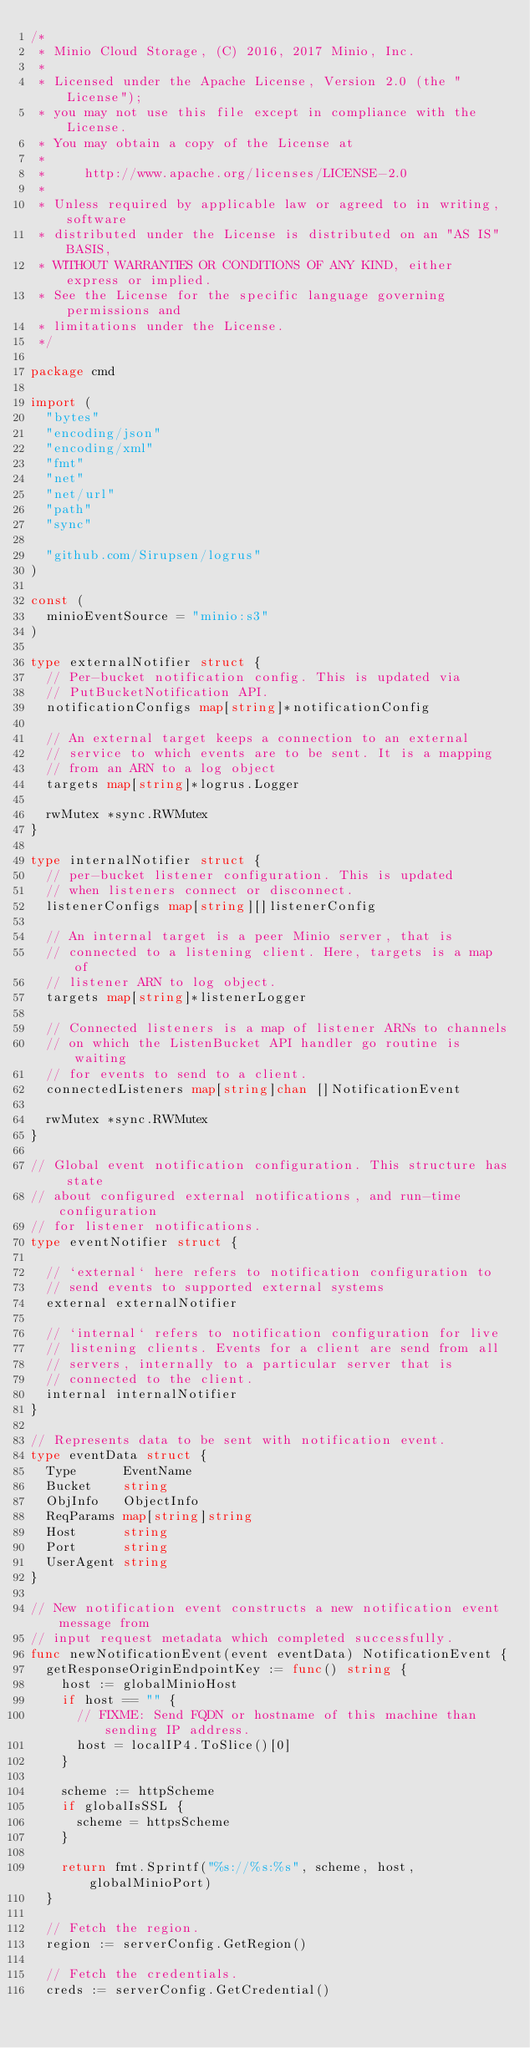<code> <loc_0><loc_0><loc_500><loc_500><_Go_>/*
 * Minio Cloud Storage, (C) 2016, 2017 Minio, Inc.
 *
 * Licensed under the Apache License, Version 2.0 (the "License");
 * you may not use this file except in compliance with the License.
 * You may obtain a copy of the License at
 *
 *     http://www.apache.org/licenses/LICENSE-2.0
 *
 * Unless required by applicable law or agreed to in writing, software
 * distributed under the License is distributed on an "AS IS" BASIS,
 * WITHOUT WARRANTIES OR CONDITIONS OF ANY KIND, either express or implied.
 * See the License for the specific language governing permissions and
 * limitations under the License.
 */

package cmd

import (
	"bytes"
	"encoding/json"
	"encoding/xml"
	"fmt"
	"net"
	"net/url"
	"path"
	"sync"

	"github.com/Sirupsen/logrus"
)

const (
	minioEventSource = "minio:s3"
)

type externalNotifier struct {
	// Per-bucket notification config. This is updated via
	// PutBucketNotification API.
	notificationConfigs map[string]*notificationConfig

	// An external target keeps a connection to an external
	// service to which events are to be sent. It is a mapping
	// from an ARN to a log object
	targets map[string]*logrus.Logger

	rwMutex *sync.RWMutex
}

type internalNotifier struct {
	// per-bucket listener configuration. This is updated
	// when listeners connect or disconnect.
	listenerConfigs map[string][]listenerConfig

	// An internal target is a peer Minio server, that is
	// connected to a listening client. Here, targets is a map of
	// listener ARN to log object.
	targets map[string]*listenerLogger

	// Connected listeners is a map of listener ARNs to channels
	// on which the ListenBucket API handler go routine is waiting
	// for events to send to a client.
	connectedListeners map[string]chan []NotificationEvent

	rwMutex *sync.RWMutex
}

// Global event notification configuration. This structure has state
// about configured external notifications, and run-time configuration
// for listener notifications.
type eventNotifier struct {

	// `external` here refers to notification configuration to
	// send events to supported external systems
	external externalNotifier

	// `internal` refers to notification configuration for live
	// listening clients. Events for a client are send from all
	// servers, internally to a particular server that is
	// connected to the client.
	internal internalNotifier
}

// Represents data to be sent with notification event.
type eventData struct {
	Type      EventName
	Bucket    string
	ObjInfo   ObjectInfo
	ReqParams map[string]string
	Host      string
	Port      string
	UserAgent string
}

// New notification event constructs a new notification event message from
// input request metadata which completed successfully.
func newNotificationEvent(event eventData) NotificationEvent {
	getResponseOriginEndpointKey := func() string {
		host := globalMinioHost
		if host == "" {
			// FIXME: Send FQDN or hostname of this machine than sending IP address.
			host = localIP4.ToSlice()[0]
		}

		scheme := httpScheme
		if globalIsSSL {
			scheme = httpsScheme
		}

		return fmt.Sprintf("%s://%s:%s", scheme, host, globalMinioPort)
	}

	// Fetch the region.
	region := serverConfig.GetRegion()

	// Fetch the credentials.
	creds := serverConfig.GetCredential()
</code> 